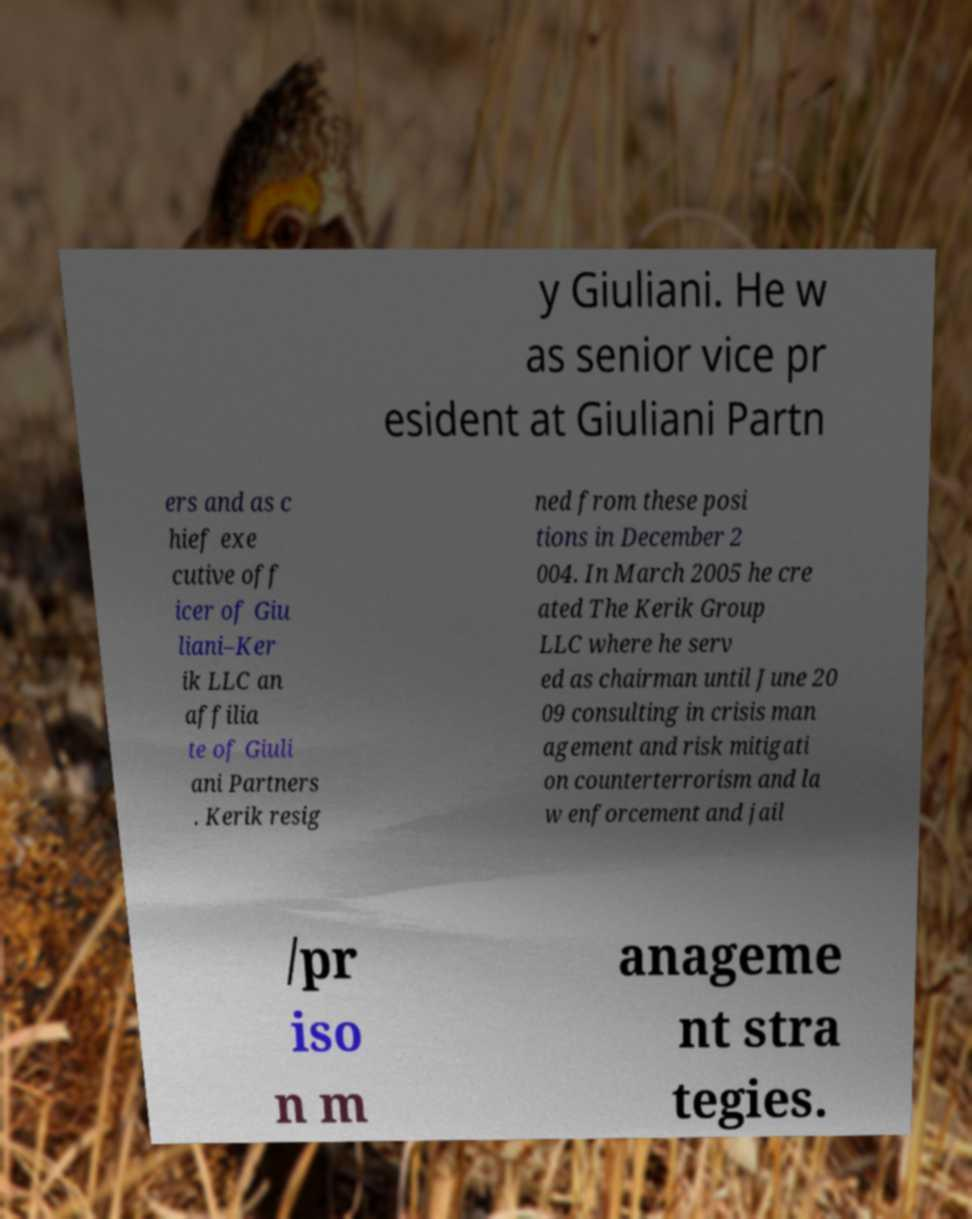I need the written content from this picture converted into text. Can you do that? y Giuliani. He w as senior vice pr esident at Giuliani Partn ers and as c hief exe cutive off icer of Giu liani–Ker ik LLC an affilia te of Giuli ani Partners . Kerik resig ned from these posi tions in December 2 004. In March 2005 he cre ated The Kerik Group LLC where he serv ed as chairman until June 20 09 consulting in crisis man agement and risk mitigati on counterterrorism and la w enforcement and jail /pr iso n m anageme nt stra tegies. 